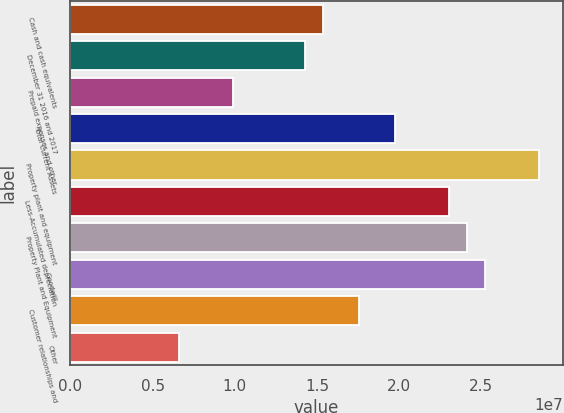<chart> <loc_0><loc_0><loc_500><loc_500><bar_chart><fcel>Cash and cash equivalents<fcel>December 31 2016 and 2017<fcel>Prepaid expenses and other<fcel>Total Current Assets<fcel>Property plant and equipment<fcel>Less-Accumulated depreciation<fcel>Property Plant and Equipment<fcel>Goodwill<fcel>Customer relationships and<fcel>Other<nl><fcel>1.53608e+07<fcel>1.42637e+07<fcel>9.8753e+06<fcel>1.97492e+07<fcel>2.8526e+07<fcel>2.30405e+07<fcel>2.41376e+07<fcel>2.52347e+07<fcel>1.7555e+07<fcel>6.584e+06<nl></chart> 